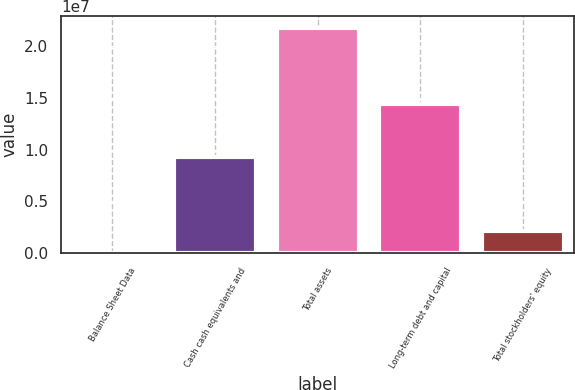<chart> <loc_0><loc_0><loc_500><loc_500><bar_chart><fcel>Balance Sheet Data<fcel>Cash cash equivalents and<fcel>Total assets<fcel>Long-term debt and capital<fcel>Total stockholders' equity<nl><fcel>2014<fcel>9.23689e+06<fcel>2.17565e+07<fcel>1.443e+07<fcel>2.17746e+06<nl></chart> 